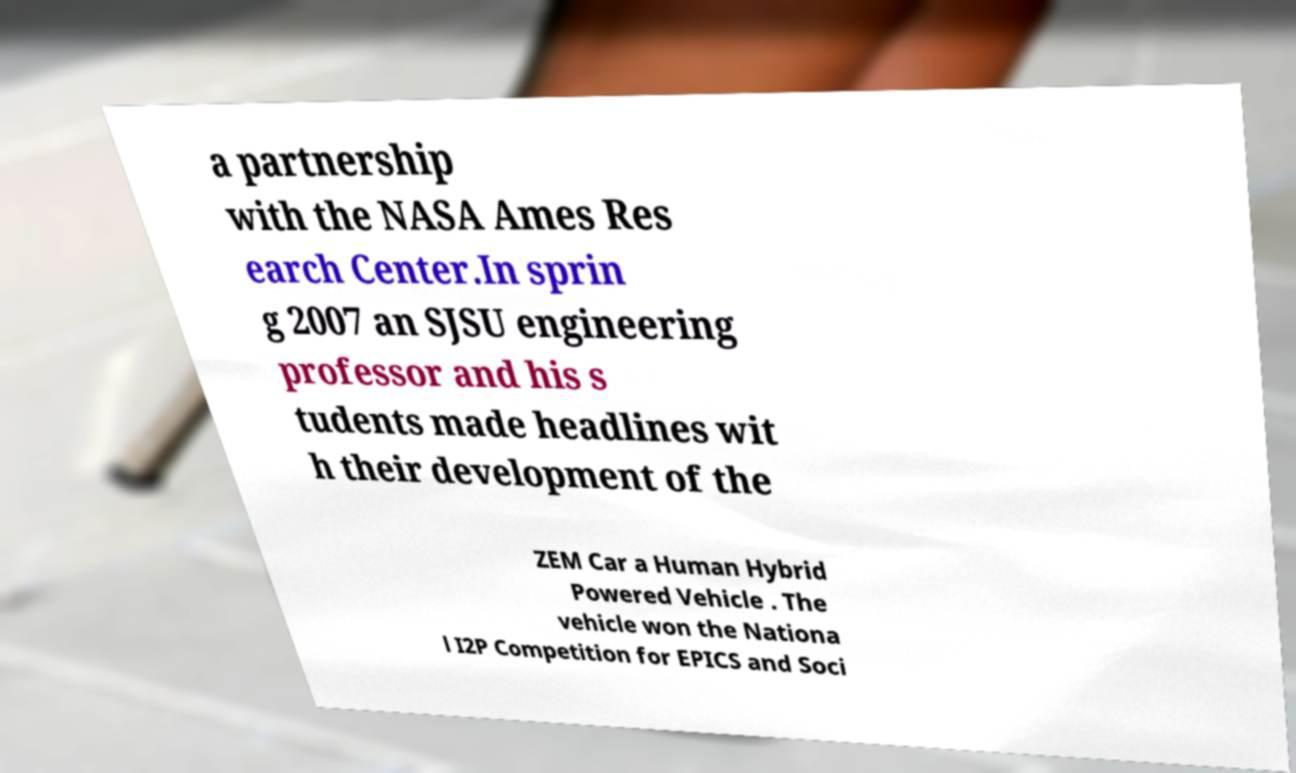Please identify and transcribe the text found in this image. a partnership with the NASA Ames Res earch Center.In sprin g 2007 an SJSU engineering professor and his s tudents made headlines wit h their development of the ZEM Car a Human Hybrid Powered Vehicle . The vehicle won the Nationa l I2P Competition for EPICS and Soci 